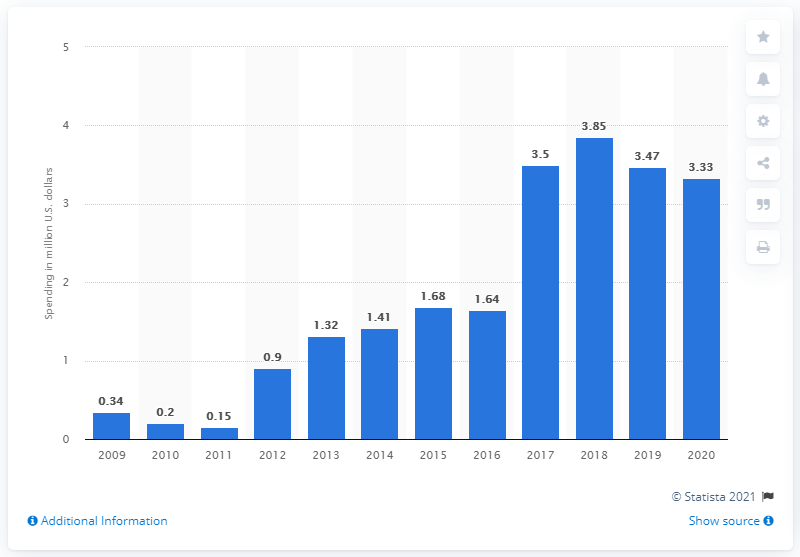Draw attention to some important aspects in this diagram. In 2020, Samsung spent an estimated 3.33 on lobbying in the United States. Samsung significantly increased its lobbying spending in the U.S. market in the year 2017. 